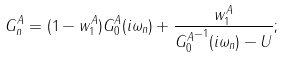<formula> <loc_0><loc_0><loc_500><loc_500>G ^ { A } _ { n } = ( 1 - w ^ { A } _ { 1 } ) G ^ { A } _ { 0 } ( i \omega _ { n } ) + \frac { w ^ { A } _ { 1 } } { { G ^ { A } _ { 0 } } ^ { - 1 } ( i \omega _ { n } ) - U } ;</formula> 